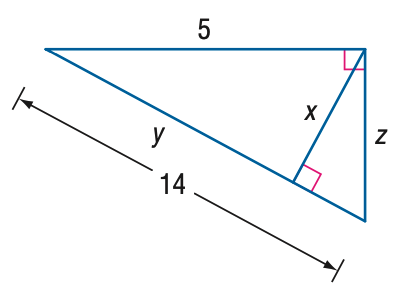Question: Find y.
Choices:
A. \frac { 5 } { 14 }
B. \frac { 25 } { 14 }
C. 5
D. \frac { 171 } { 14 }
Answer with the letter. Answer: B Question: Find x.
Choices:
A. \frac { 5 } { 14 } \sqrt { 19 }
B. \frac { 15 } { 14 } \sqrt { 19 }
C. 5
D. 14
Answer with the letter. Answer: B 